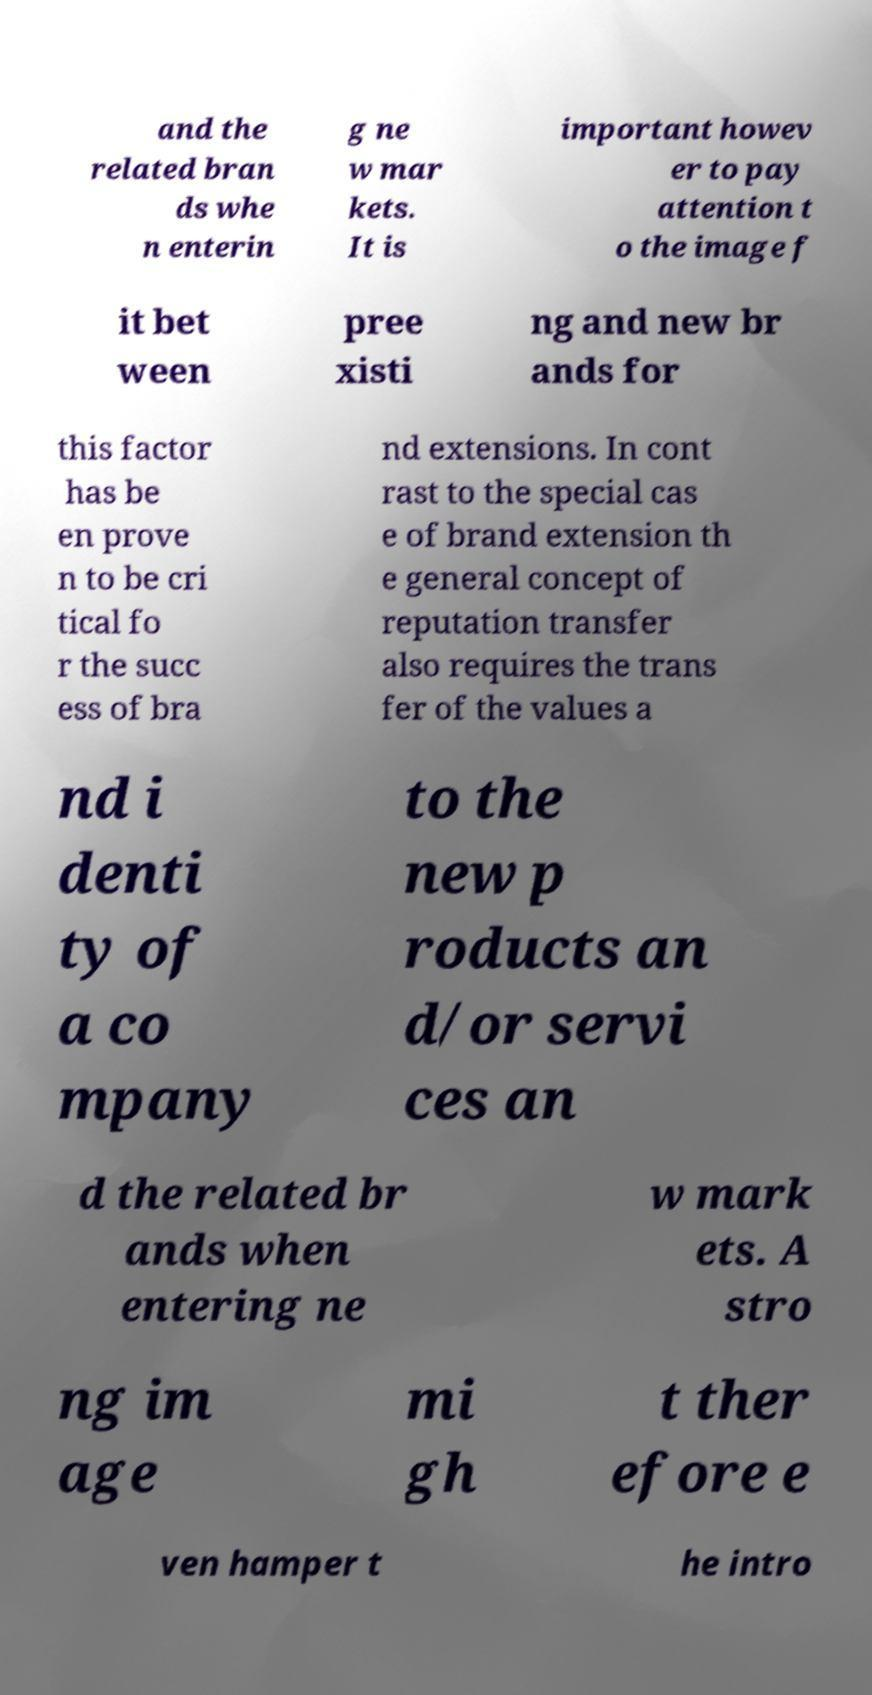Can you read and provide the text displayed in the image?This photo seems to have some interesting text. Can you extract and type it out for me? and the related bran ds whe n enterin g ne w mar kets. It is important howev er to pay attention t o the image f it bet ween pree xisti ng and new br ands for this factor has be en prove n to be cri tical fo r the succ ess of bra nd extensions. In cont rast to the special cas e of brand extension th e general concept of reputation transfer also requires the trans fer of the values a nd i denti ty of a co mpany to the new p roducts an d/or servi ces an d the related br ands when entering ne w mark ets. A stro ng im age mi gh t ther efore e ven hamper t he intro 